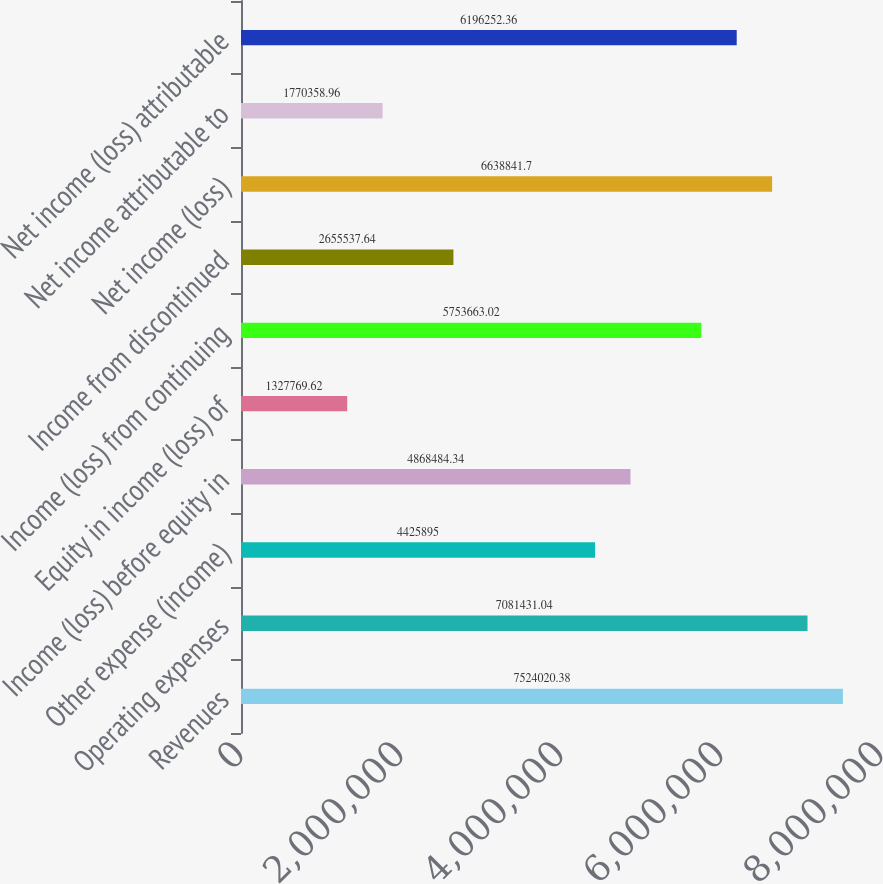<chart> <loc_0><loc_0><loc_500><loc_500><bar_chart><fcel>Revenues<fcel>Operating expenses<fcel>Other expense (income)<fcel>Income (loss) before equity in<fcel>Equity in income (loss) of<fcel>Income (loss) from continuing<fcel>Income from discontinued<fcel>Net income (loss)<fcel>Net income attributable to<fcel>Net income (loss) attributable<nl><fcel>7.52402e+06<fcel>7.08143e+06<fcel>4.4259e+06<fcel>4.86848e+06<fcel>1.32777e+06<fcel>5.75366e+06<fcel>2.65554e+06<fcel>6.63884e+06<fcel>1.77036e+06<fcel>6.19625e+06<nl></chart> 